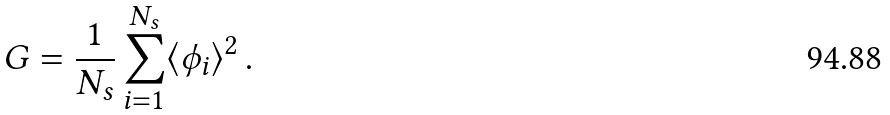<formula> <loc_0><loc_0><loc_500><loc_500>G = \frac { 1 } { N _ { s } } \sum _ { i = 1 } ^ { N _ { s } } \langle \phi _ { i } \rangle ^ { 2 } \, .</formula> 